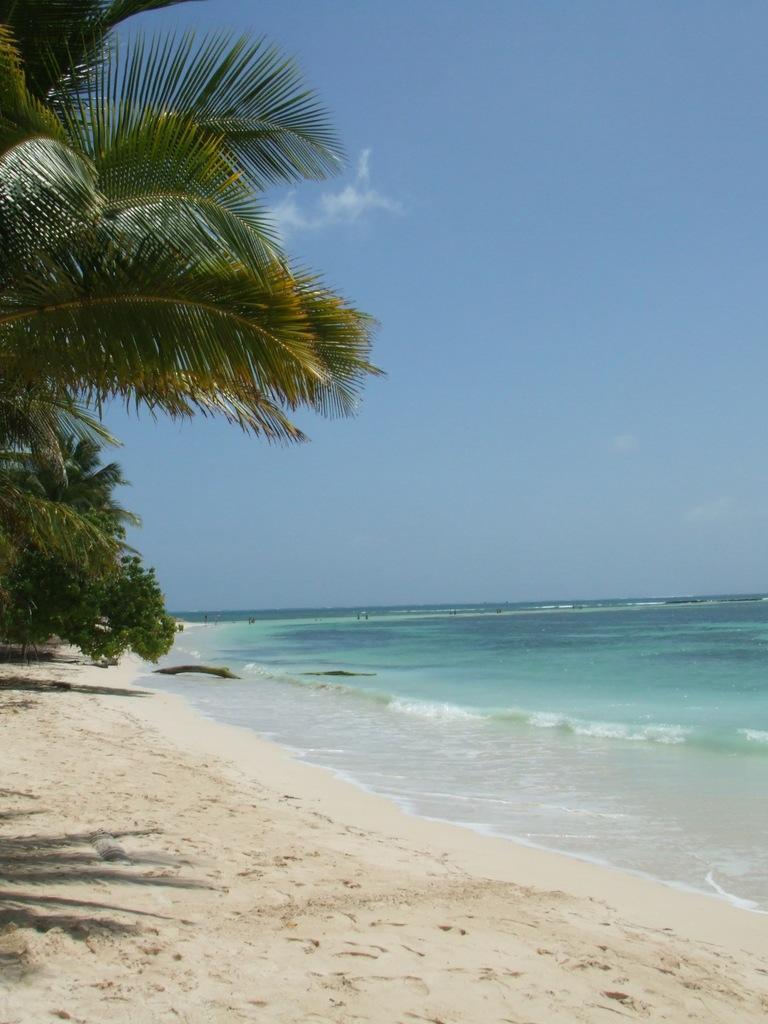Please provide a concise description of this image. In this image I can see the trees and the sand. To the side of the trees I can see the water. In the background I can see the clouds and the sky. 